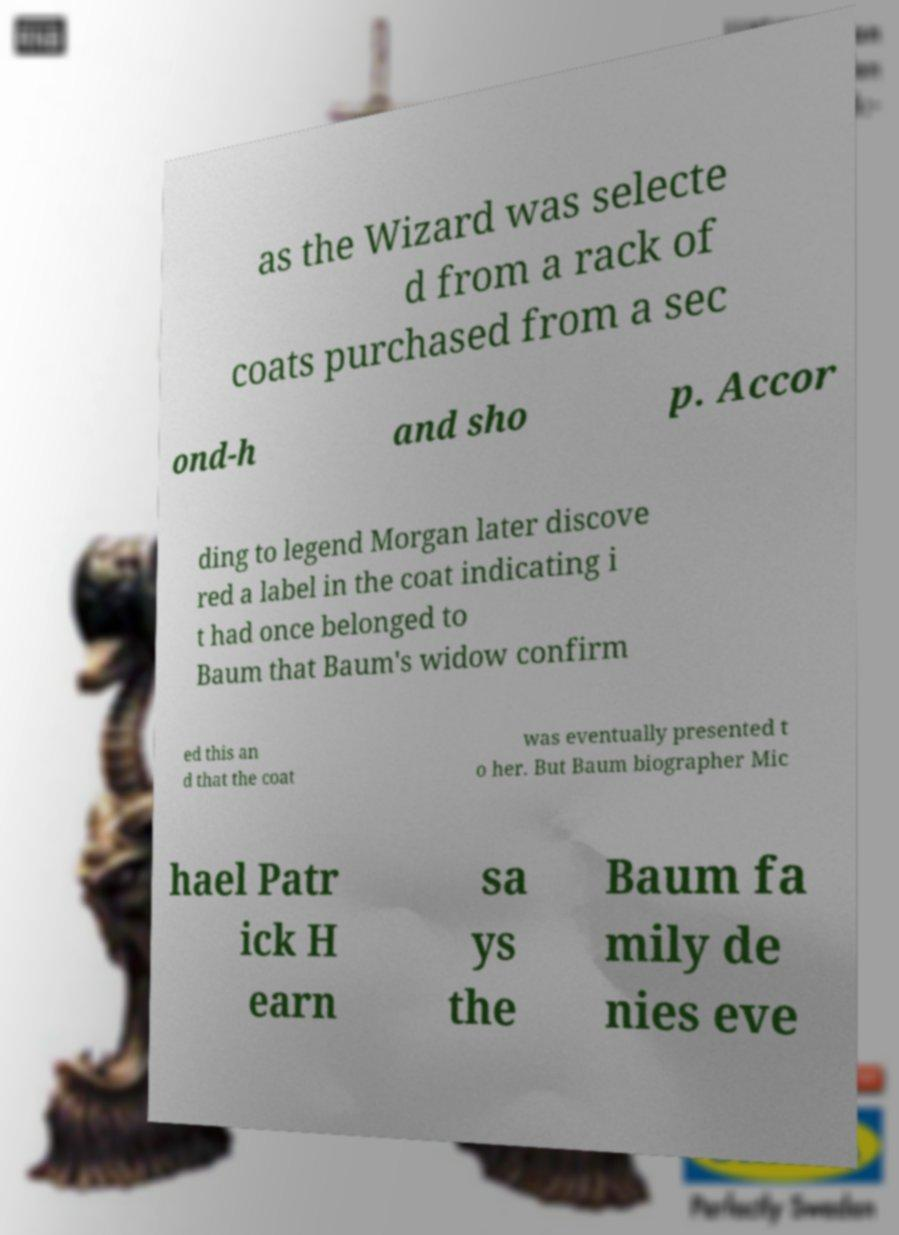For documentation purposes, I need the text within this image transcribed. Could you provide that? as the Wizard was selecte d from a rack of coats purchased from a sec ond-h and sho p. Accor ding to legend Morgan later discove red a label in the coat indicating i t had once belonged to Baum that Baum's widow confirm ed this an d that the coat was eventually presented t o her. But Baum biographer Mic hael Patr ick H earn sa ys the Baum fa mily de nies eve 